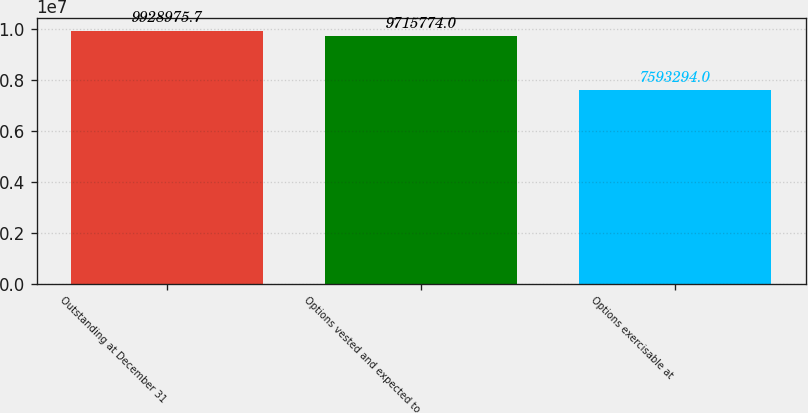Convert chart. <chart><loc_0><loc_0><loc_500><loc_500><bar_chart><fcel>Outstanding at December 31<fcel>Options vested and expected to<fcel>Options exercisable at<nl><fcel>9.92898e+06<fcel>9.71577e+06<fcel>7.59329e+06<nl></chart> 